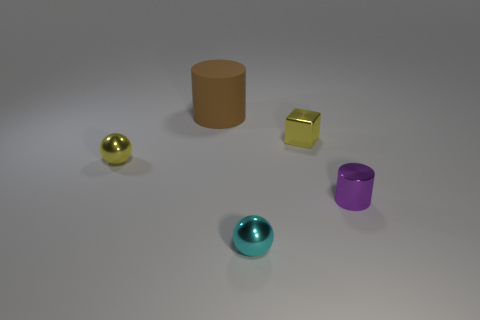Can you tell me about the lighting in this scene? The scene appears to be illuminated by a soft, diffused overhead light source creating subtle shadows beneath each object. It suggests an indoor setting, likely a studio or controlled environment for displaying the objects prominently. 